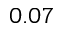Convert formula to latex. <formula><loc_0><loc_0><loc_500><loc_500>0 . 0 7</formula> 